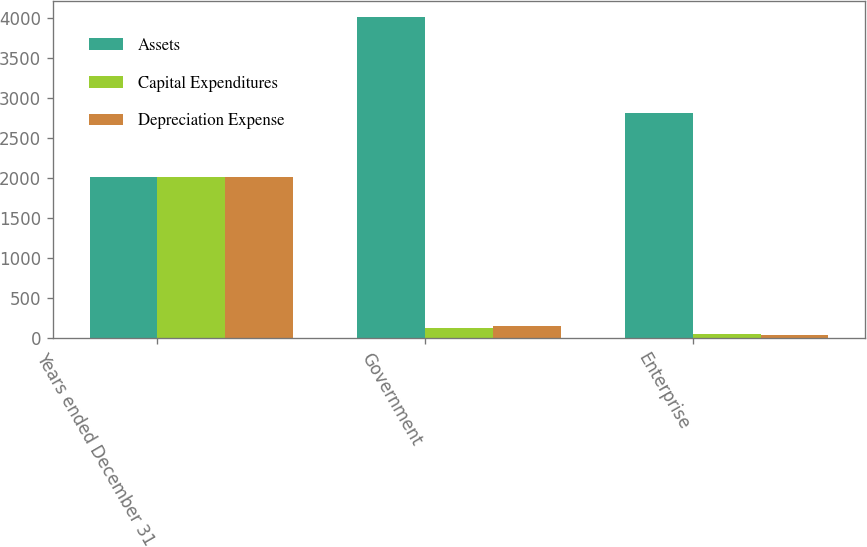Convert chart to OTSL. <chart><loc_0><loc_0><loc_500><loc_500><stacked_bar_chart><ecel><fcel>Years ended December 31<fcel>Government<fcel>Enterprise<nl><fcel>Assets<fcel>2013<fcel>4013<fcel>2820<nl><fcel>Capital Expenditures<fcel>2013<fcel>132<fcel>59<nl><fcel>Depreciation Expense<fcel>2013<fcel>154<fcel>48<nl></chart> 